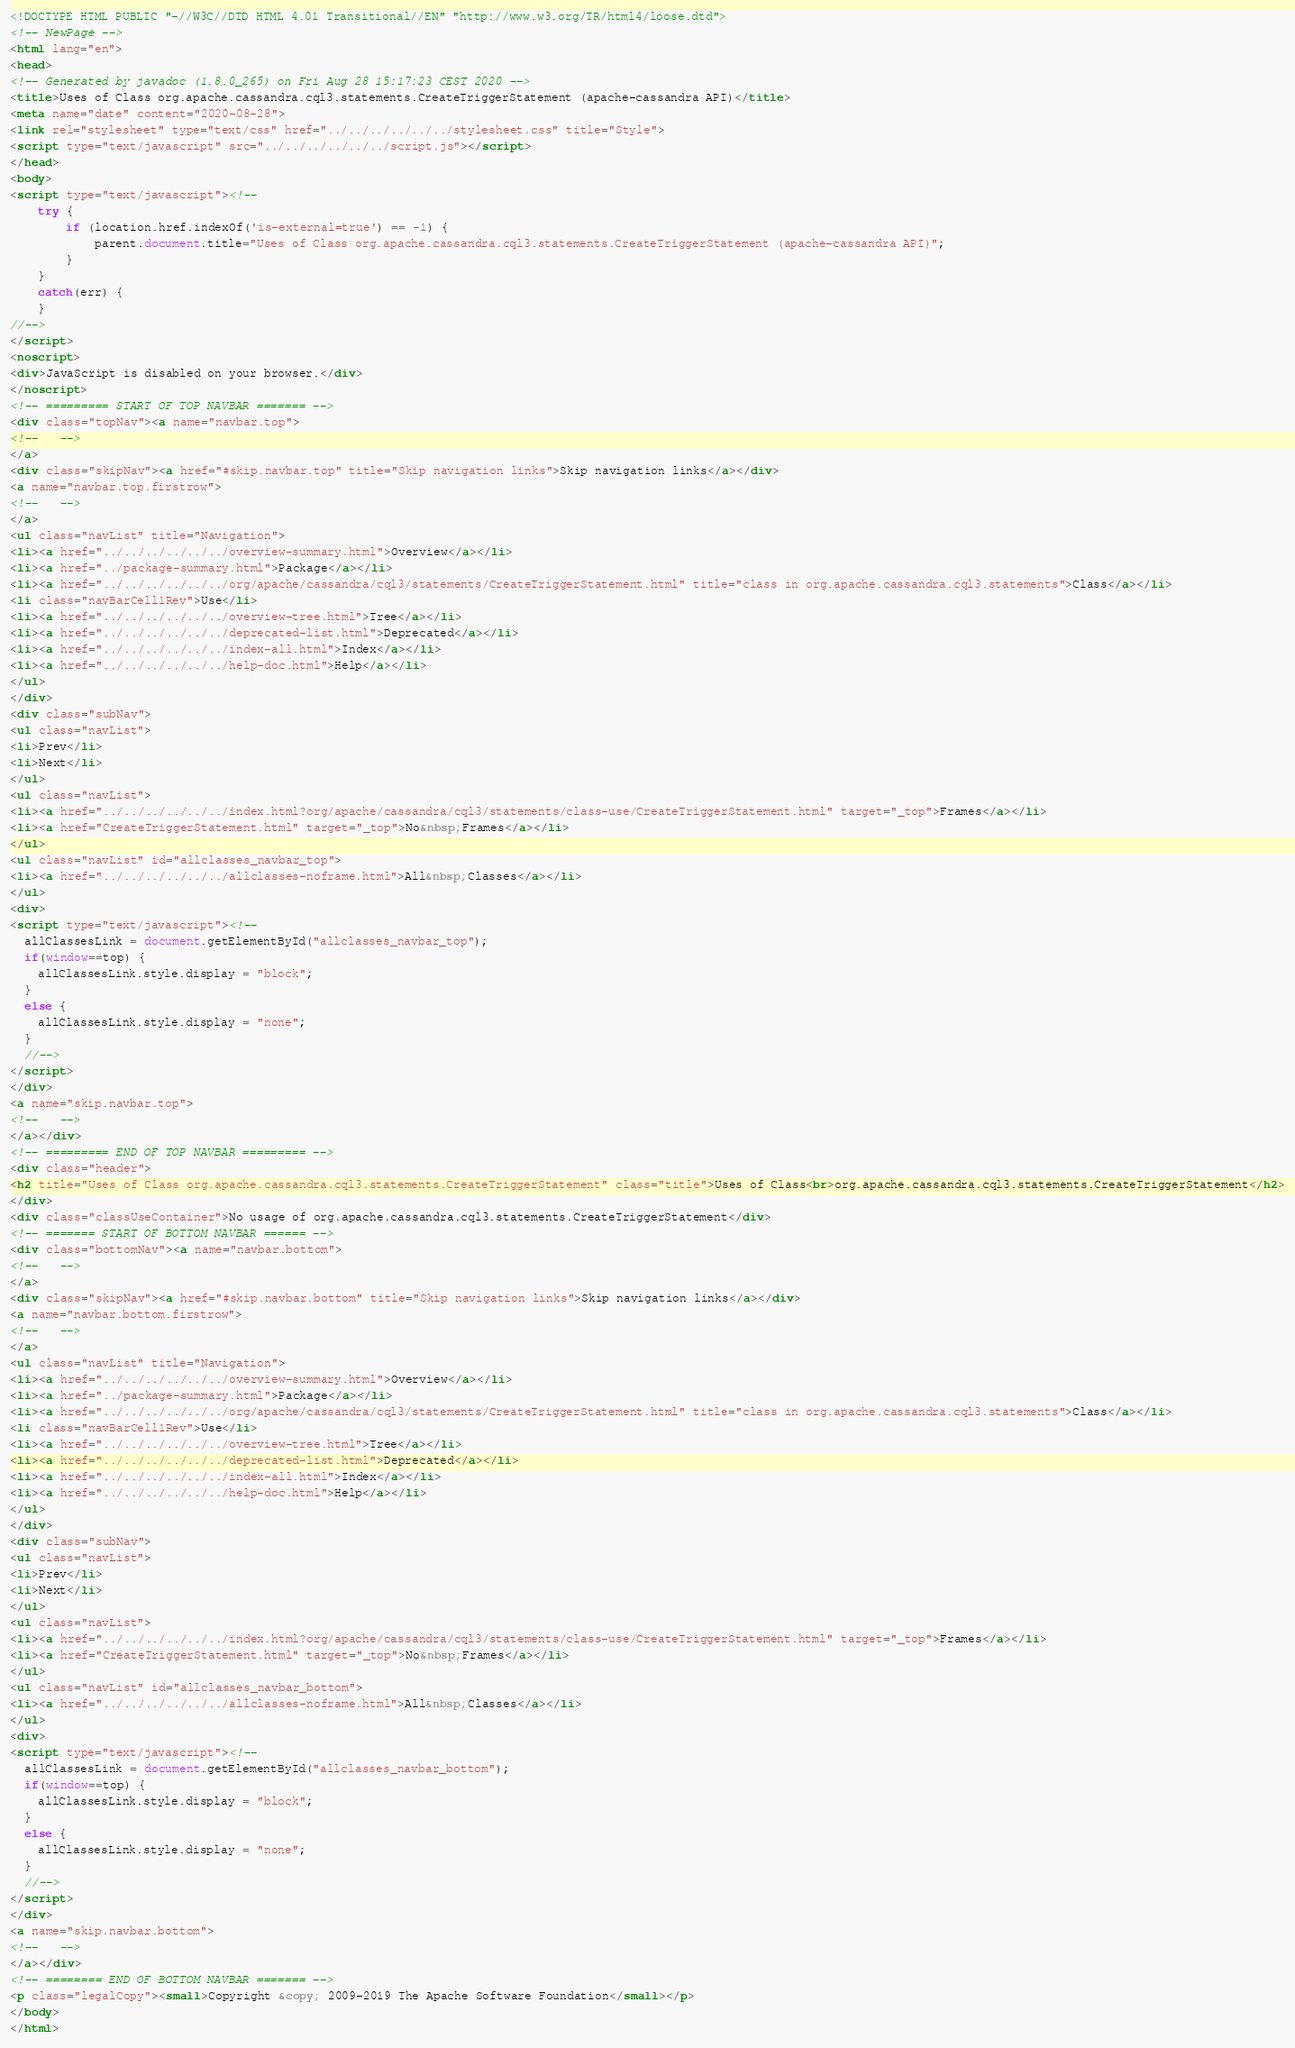<code> <loc_0><loc_0><loc_500><loc_500><_HTML_><!DOCTYPE HTML PUBLIC "-//W3C//DTD HTML 4.01 Transitional//EN" "http://www.w3.org/TR/html4/loose.dtd">
<!-- NewPage -->
<html lang="en">
<head>
<!-- Generated by javadoc (1.8.0_265) on Fri Aug 28 15:17:23 CEST 2020 -->
<title>Uses of Class org.apache.cassandra.cql3.statements.CreateTriggerStatement (apache-cassandra API)</title>
<meta name="date" content="2020-08-28">
<link rel="stylesheet" type="text/css" href="../../../../../../stylesheet.css" title="Style">
<script type="text/javascript" src="../../../../../../script.js"></script>
</head>
<body>
<script type="text/javascript"><!--
    try {
        if (location.href.indexOf('is-external=true') == -1) {
            parent.document.title="Uses of Class org.apache.cassandra.cql3.statements.CreateTriggerStatement (apache-cassandra API)";
        }
    }
    catch(err) {
    }
//-->
</script>
<noscript>
<div>JavaScript is disabled on your browser.</div>
</noscript>
<!-- ========= START OF TOP NAVBAR ======= -->
<div class="topNav"><a name="navbar.top">
<!--   -->
</a>
<div class="skipNav"><a href="#skip.navbar.top" title="Skip navigation links">Skip navigation links</a></div>
<a name="navbar.top.firstrow">
<!--   -->
</a>
<ul class="navList" title="Navigation">
<li><a href="../../../../../../overview-summary.html">Overview</a></li>
<li><a href="../package-summary.html">Package</a></li>
<li><a href="../../../../../../org/apache/cassandra/cql3/statements/CreateTriggerStatement.html" title="class in org.apache.cassandra.cql3.statements">Class</a></li>
<li class="navBarCell1Rev">Use</li>
<li><a href="../../../../../../overview-tree.html">Tree</a></li>
<li><a href="../../../../../../deprecated-list.html">Deprecated</a></li>
<li><a href="../../../../../../index-all.html">Index</a></li>
<li><a href="../../../../../../help-doc.html">Help</a></li>
</ul>
</div>
<div class="subNav">
<ul class="navList">
<li>Prev</li>
<li>Next</li>
</ul>
<ul class="navList">
<li><a href="../../../../../../index.html?org/apache/cassandra/cql3/statements/class-use/CreateTriggerStatement.html" target="_top">Frames</a></li>
<li><a href="CreateTriggerStatement.html" target="_top">No&nbsp;Frames</a></li>
</ul>
<ul class="navList" id="allclasses_navbar_top">
<li><a href="../../../../../../allclasses-noframe.html">All&nbsp;Classes</a></li>
</ul>
<div>
<script type="text/javascript"><!--
  allClassesLink = document.getElementById("allclasses_navbar_top");
  if(window==top) {
    allClassesLink.style.display = "block";
  }
  else {
    allClassesLink.style.display = "none";
  }
  //-->
</script>
</div>
<a name="skip.navbar.top">
<!--   -->
</a></div>
<!-- ========= END OF TOP NAVBAR ========= -->
<div class="header">
<h2 title="Uses of Class org.apache.cassandra.cql3.statements.CreateTriggerStatement" class="title">Uses of Class<br>org.apache.cassandra.cql3.statements.CreateTriggerStatement</h2>
</div>
<div class="classUseContainer">No usage of org.apache.cassandra.cql3.statements.CreateTriggerStatement</div>
<!-- ======= START OF BOTTOM NAVBAR ====== -->
<div class="bottomNav"><a name="navbar.bottom">
<!--   -->
</a>
<div class="skipNav"><a href="#skip.navbar.bottom" title="Skip navigation links">Skip navigation links</a></div>
<a name="navbar.bottom.firstrow">
<!--   -->
</a>
<ul class="navList" title="Navigation">
<li><a href="../../../../../../overview-summary.html">Overview</a></li>
<li><a href="../package-summary.html">Package</a></li>
<li><a href="../../../../../../org/apache/cassandra/cql3/statements/CreateTriggerStatement.html" title="class in org.apache.cassandra.cql3.statements">Class</a></li>
<li class="navBarCell1Rev">Use</li>
<li><a href="../../../../../../overview-tree.html">Tree</a></li>
<li><a href="../../../../../../deprecated-list.html">Deprecated</a></li>
<li><a href="../../../../../../index-all.html">Index</a></li>
<li><a href="../../../../../../help-doc.html">Help</a></li>
</ul>
</div>
<div class="subNav">
<ul class="navList">
<li>Prev</li>
<li>Next</li>
</ul>
<ul class="navList">
<li><a href="../../../../../../index.html?org/apache/cassandra/cql3/statements/class-use/CreateTriggerStatement.html" target="_top">Frames</a></li>
<li><a href="CreateTriggerStatement.html" target="_top">No&nbsp;Frames</a></li>
</ul>
<ul class="navList" id="allclasses_navbar_bottom">
<li><a href="../../../../../../allclasses-noframe.html">All&nbsp;Classes</a></li>
</ul>
<div>
<script type="text/javascript"><!--
  allClassesLink = document.getElementById("allclasses_navbar_bottom");
  if(window==top) {
    allClassesLink.style.display = "block";
  }
  else {
    allClassesLink.style.display = "none";
  }
  //-->
</script>
</div>
<a name="skip.navbar.bottom">
<!--   -->
</a></div>
<!-- ======== END OF BOTTOM NAVBAR ======= -->
<p class="legalCopy"><small>Copyright &copy; 2009-2019 The Apache Software Foundation</small></p>
</body>
</html>
</code> 